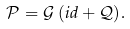Convert formula to latex. <formula><loc_0><loc_0><loc_500><loc_500>\mathcal { P } = \mathcal { G } \, ( i d + \mathcal { Q } ) .</formula> 